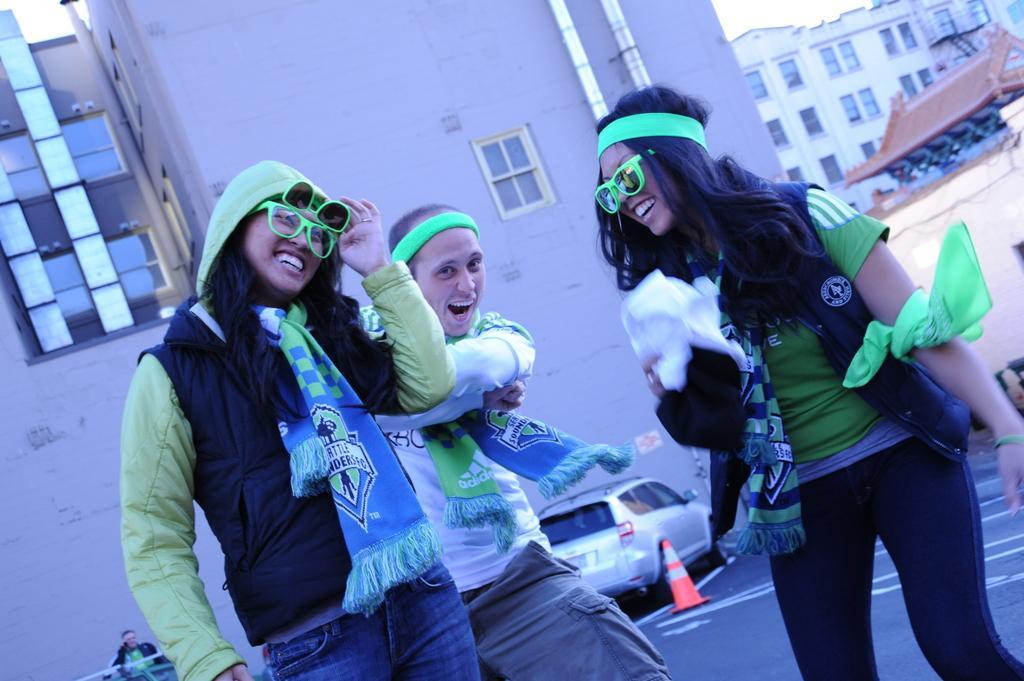Could you give a brief overview of what you see in this image? On the rights there is a woman who is wearing google, t-shirt, jacket and jeans, beside her we can see a man who is wearing, t-shirt and trouser. On the left there is another woman who is wearing goggles, hoodie and jeans. At the back there is a car which is parked near to the wall and traffic cone. In the bottom left corner there is a man who is sitting on the bench. In the background we can see many buildings. At the top there is a sky. In the top left there is a pipe near to the windows. 